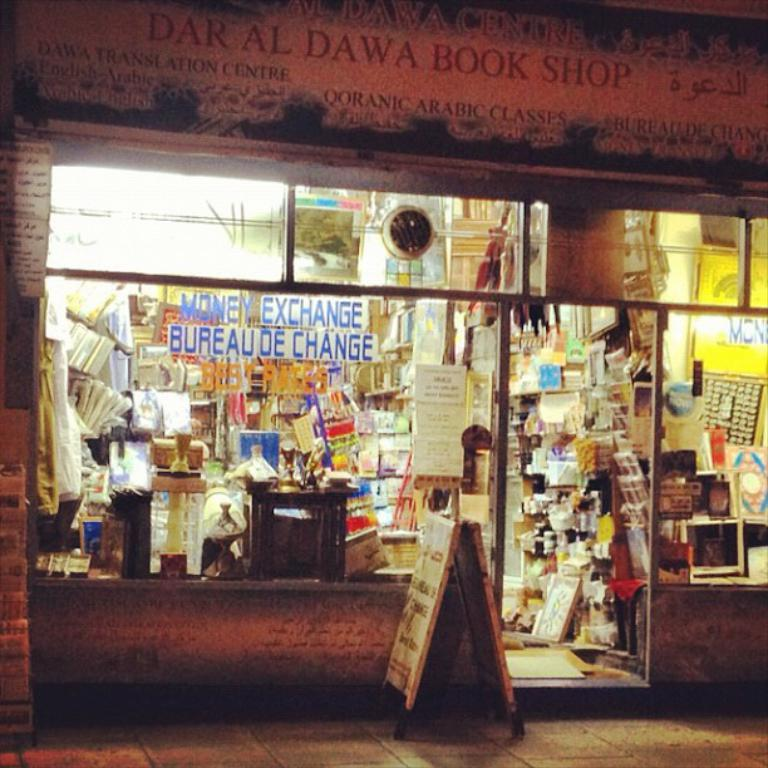<image>
Offer a succinct explanation of the picture presented. A sign sits outside of a store called Dar Al Dawa Book Shop. 